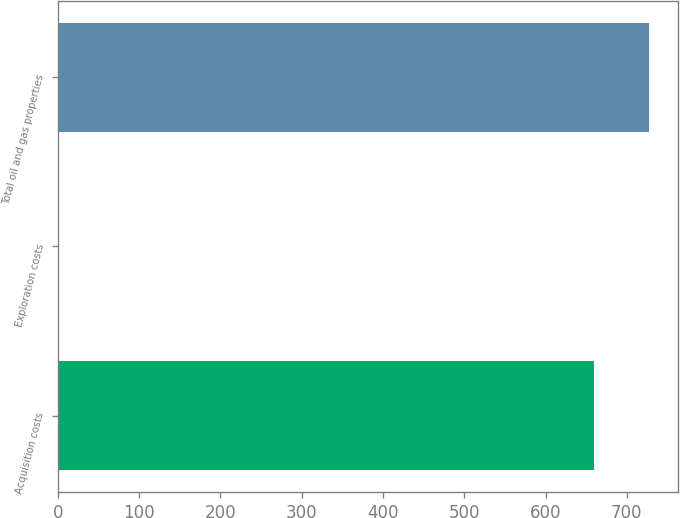Convert chart. <chart><loc_0><loc_0><loc_500><loc_500><bar_chart><fcel>Acquisition costs<fcel>Exploration costs<fcel>Total oil and gas properties<nl><fcel>660<fcel>1<fcel>727<nl></chart> 